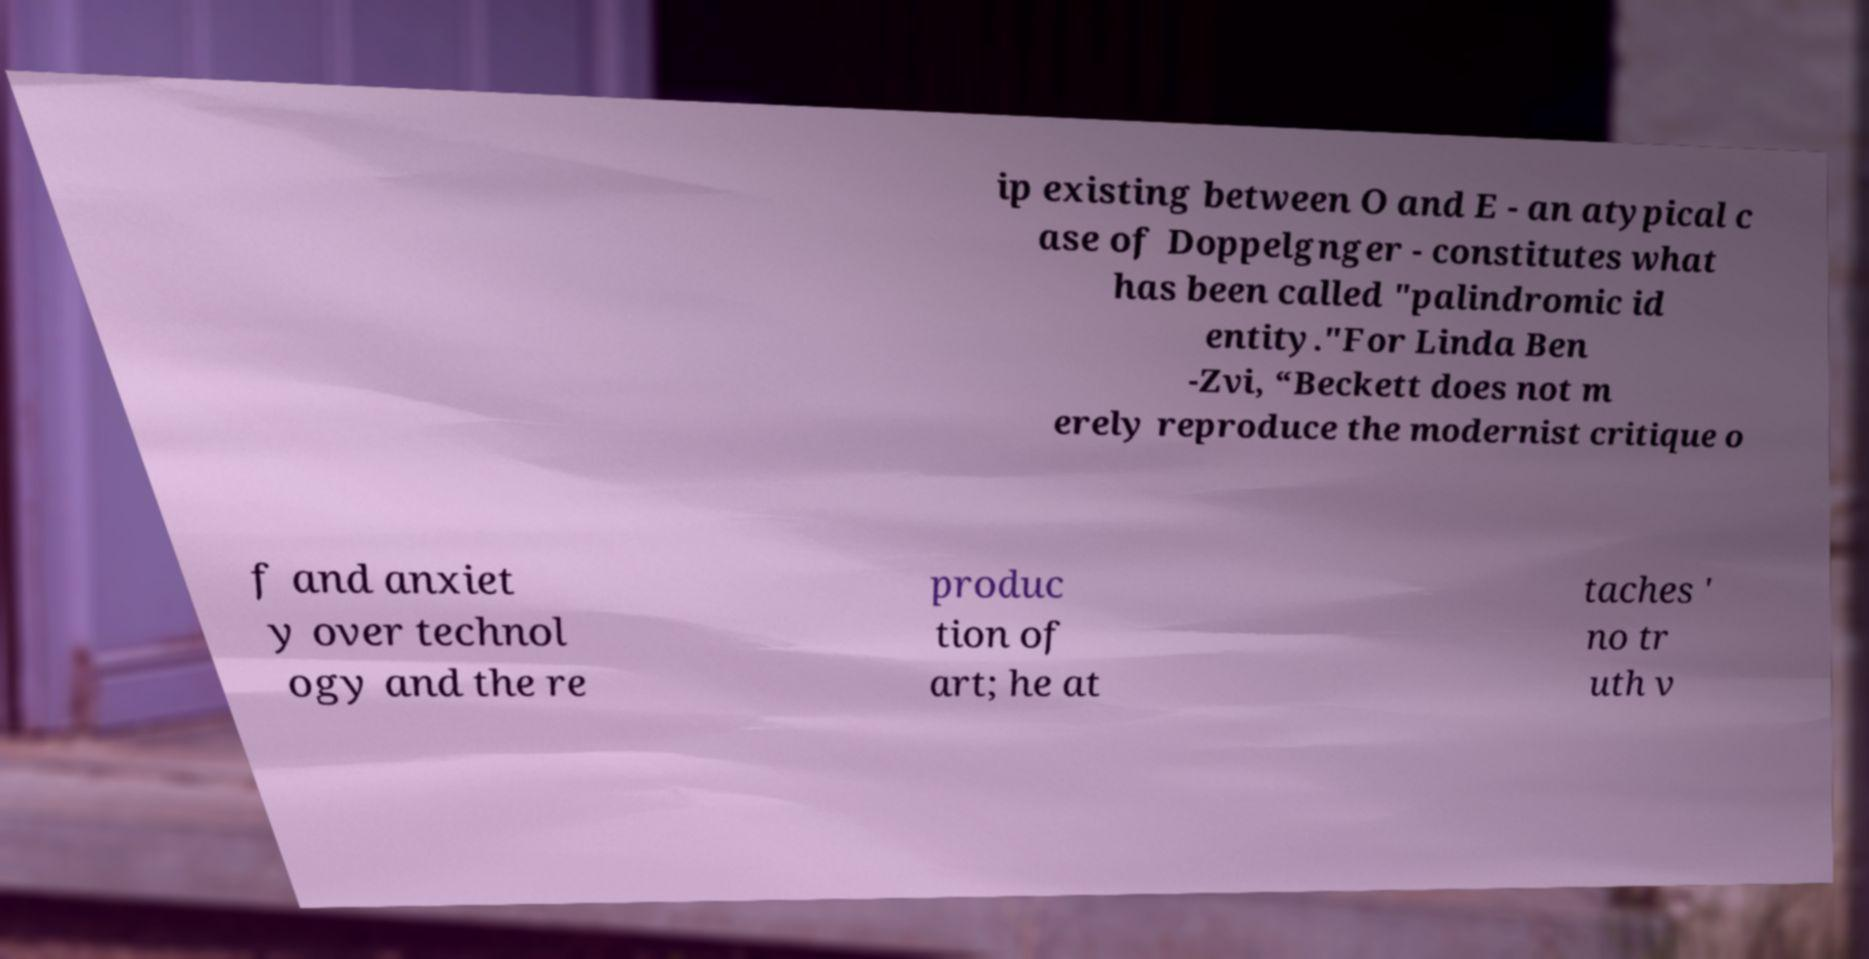Please identify and transcribe the text found in this image. ip existing between O and E - an atypical c ase of Doppelgnger - constitutes what has been called "palindromic id entity."For Linda Ben -Zvi, “Beckett does not m erely reproduce the modernist critique o f and anxiet y over technol ogy and the re produc tion of art; he at taches ' no tr uth v 